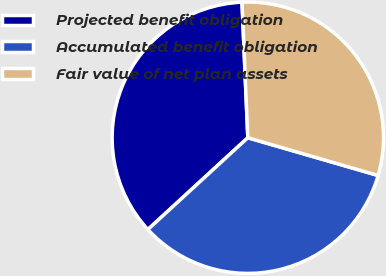Convert chart to OTSL. <chart><loc_0><loc_0><loc_500><loc_500><pie_chart><fcel>Projected benefit obligation<fcel>Accumulated benefit obligation<fcel>Fair value of net plan assets<nl><fcel>36.14%<fcel>33.68%<fcel>30.17%<nl></chart> 